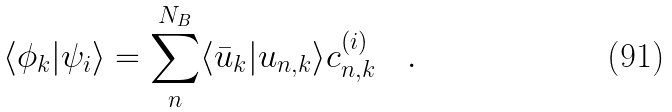Convert formula to latex. <formula><loc_0><loc_0><loc_500><loc_500>\langle \phi _ { k } | \psi _ { i } \rangle = \sum _ { n } ^ { N _ { B } } \langle \bar { u } _ { k } | u _ { n , { k } } \rangle c _ { n , { k } } ^ { ( i ) } \quad .</formula> 